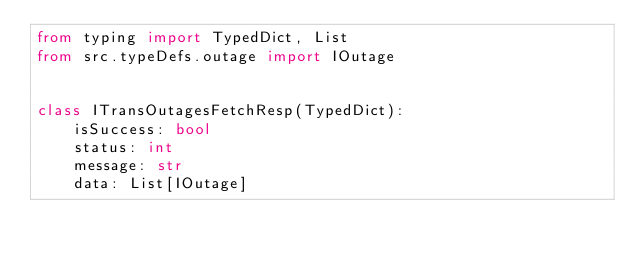Convert code to text. <code><loc_0><loc_0><loc_500><loc_500><_Python_>from typing import TypedDict, List
from src.typeDefs.outage import IOutage


class ITransOutagesFetchResp(TypedDict):
    isSuccess: bool
    status: int
    message: str
    data: List[IOutage]
</code> 